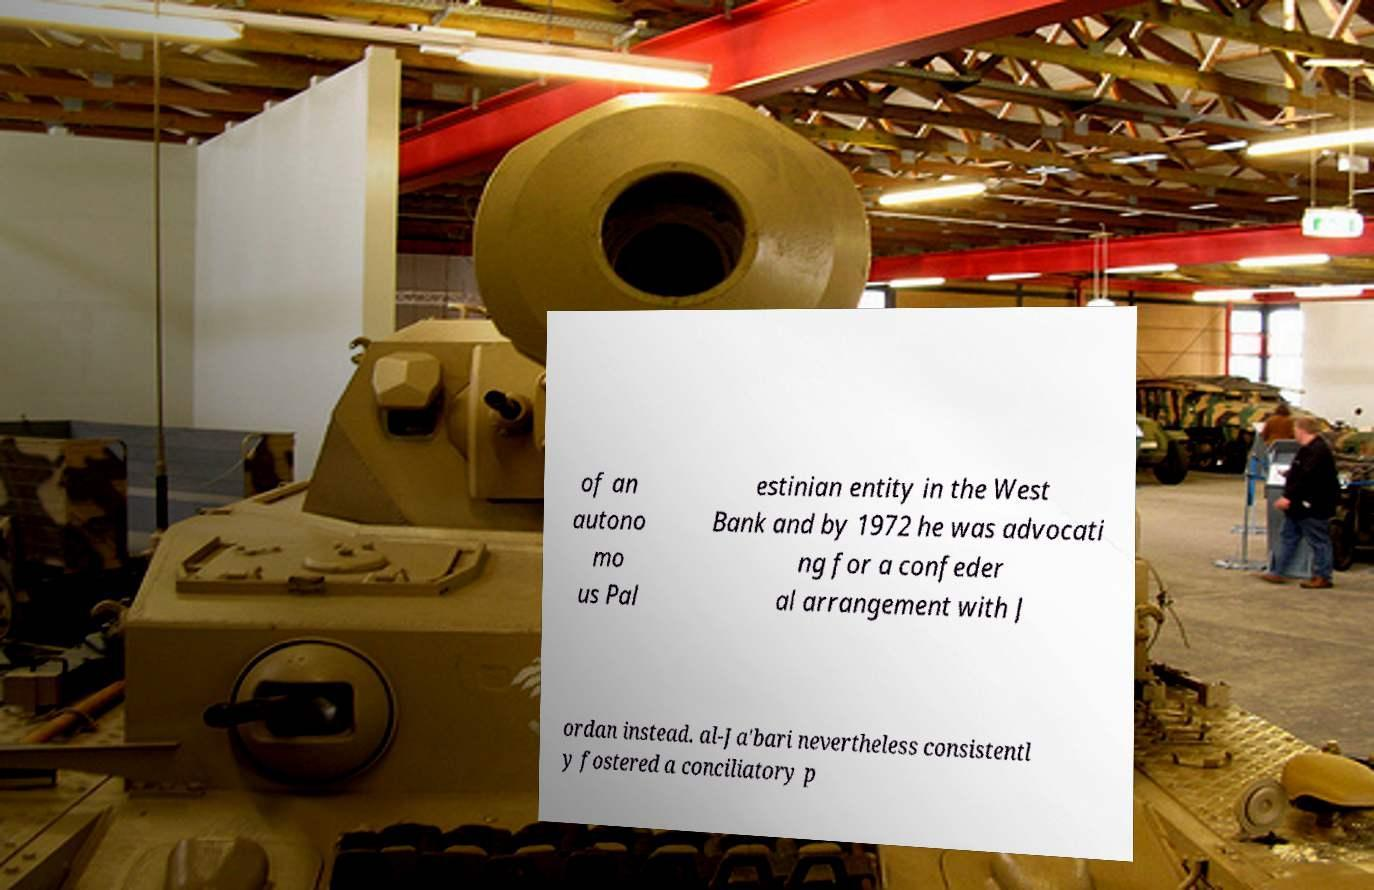Can you read and provide the text displayed in the image?This photo seems to have some interesting text. Can you extract and type it out for me? of an autono mo us Pal estinian entity in the West Bank and by 1972 he was advocati ng for a confeder al arrangement with J ordan instead. al-Ja'bari nevertheless consistentl y fostered a conciliatory p 